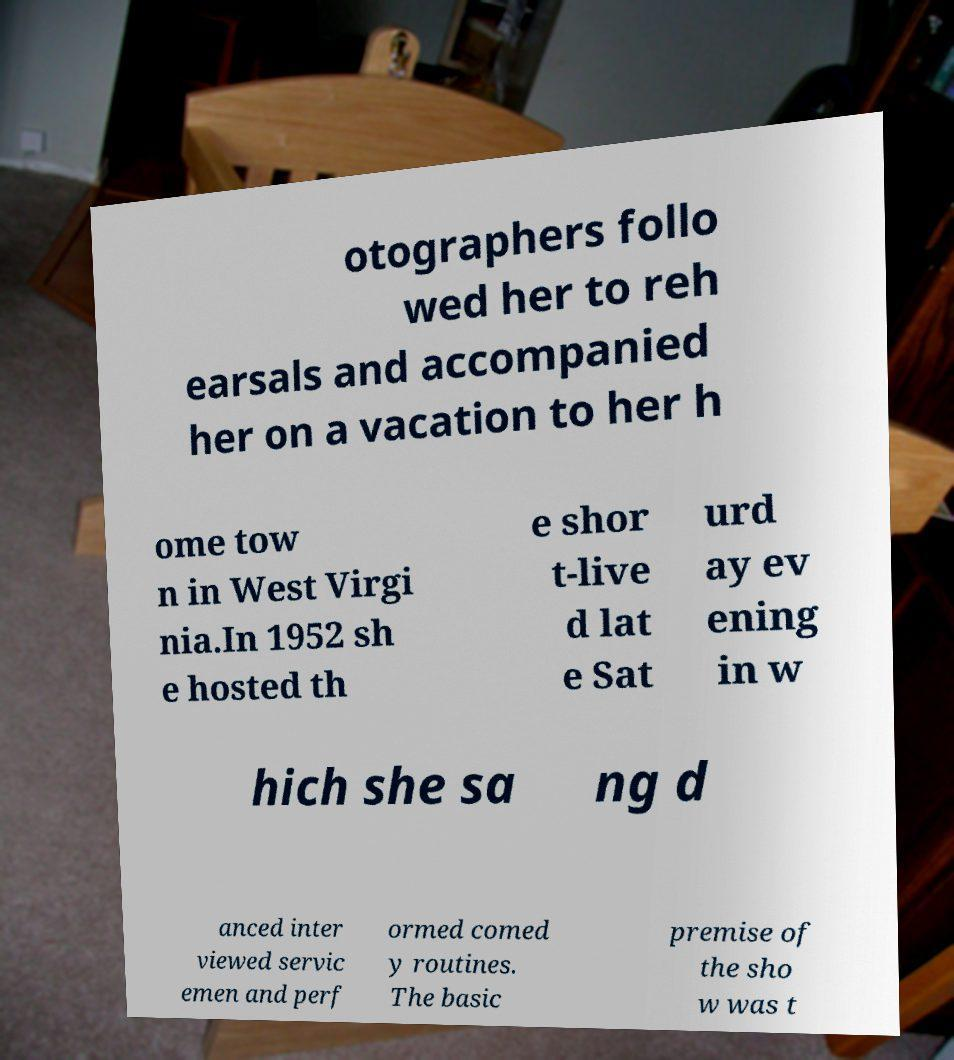Please identify and transcribe the text found in this image. otographers follo wed her to reh earsals and accompanied her on a vacation to her h ome tow n in West Virgi nia.In 1952 sh e hosted th e shor t-live d lat e Sat urd ay ev ening in w hich she sa ng d anced inter viewed servic emen and perf ormed comed y routines. The basic premise of the sho w was t 